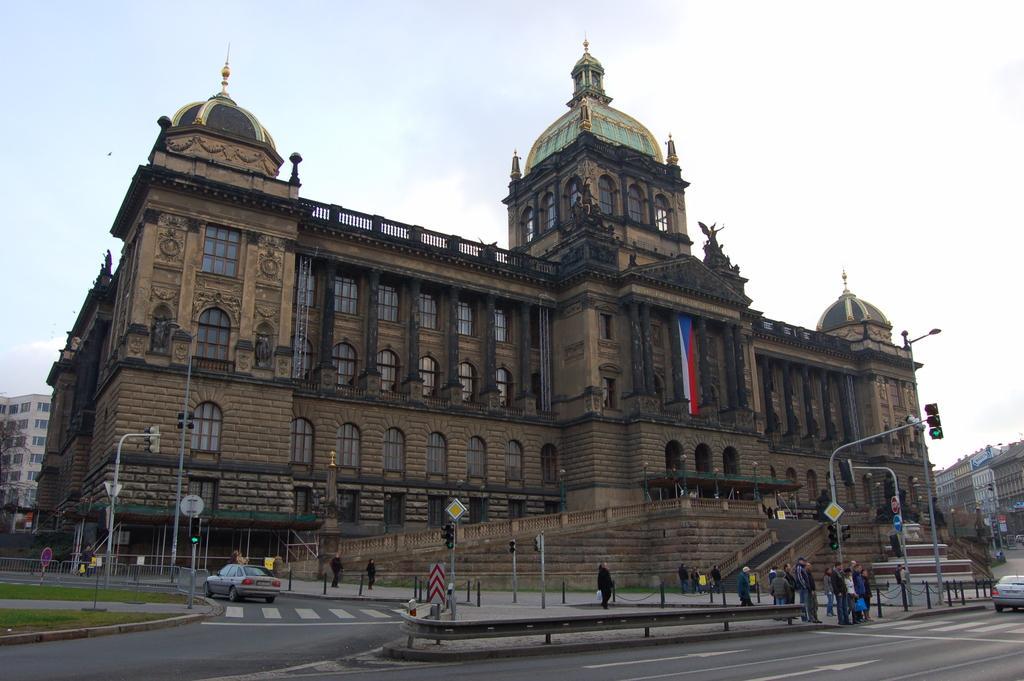Can you describe this image briefly? In the foreground of this picture, we can see the roads, poles, traffic signal poles, vehicles, and the sign boards. In the background, we can see persons, buildings, stairs, sculptures, and the sky. 